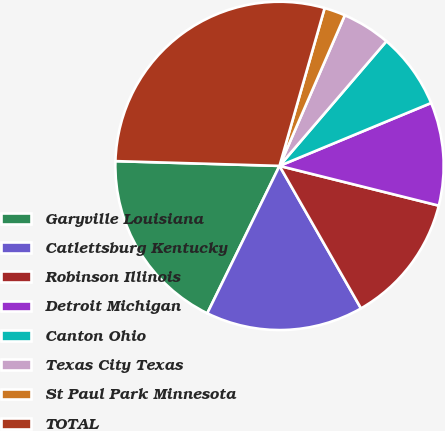Convert chart to OTSL. <chart><loc_0><loc_0><loc_500><loc_500><pie_chart><fcel>Garyville Louisiana<fcel>Catlettsburg Kentucky<fcel>Robinson Illinois<fcel>Detroit Michigan<fcel>Canton Ohio<fcel>Texas City Texas<fcel>St Paul Park Minnesota<fcel>TOTAL<nl><fcel>18.21%<fcel>15.52%<fcel>12.84%<fcel>10.15%<fcel>7.46%<fcel>4.77%<fcel>2.08%<fcel>28.97%<nl></chart> 